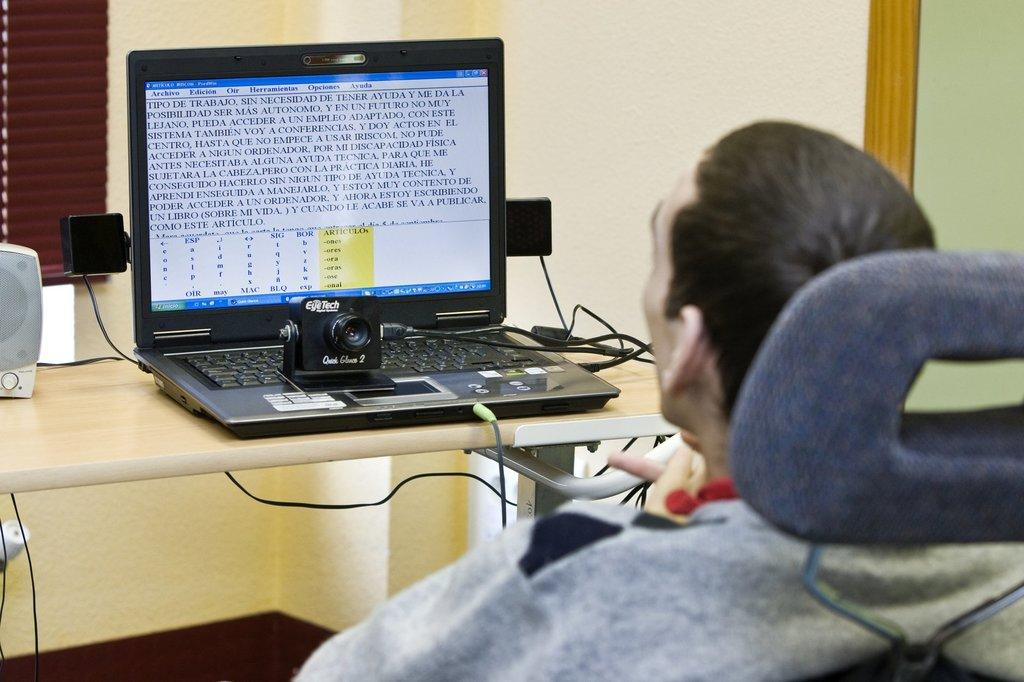Where is the person located in the image? The person is sitting in a chair in the right corner of the image. What is the person facing in the image? The person is facing a table in the image. What electronic device is on the table? There is a laptop on the table. What else can be seen on the table besides the laptop? There are other objects on the table. How many babies are crawling under the table in the image? There are no babies present in the image, and therefore no crawling babies can be observed. 